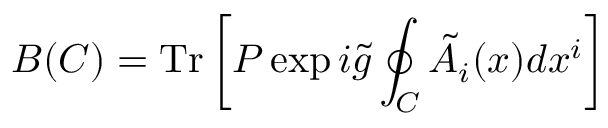<formula> <loc_0><loc_0><loc_500><loc_500>B ( C ) = T r \left [ P \exp i \tilde { g } \oint _ { C } \tilde { A } _ { i } ( x ) d x ^ { i } \right ]</formula> 